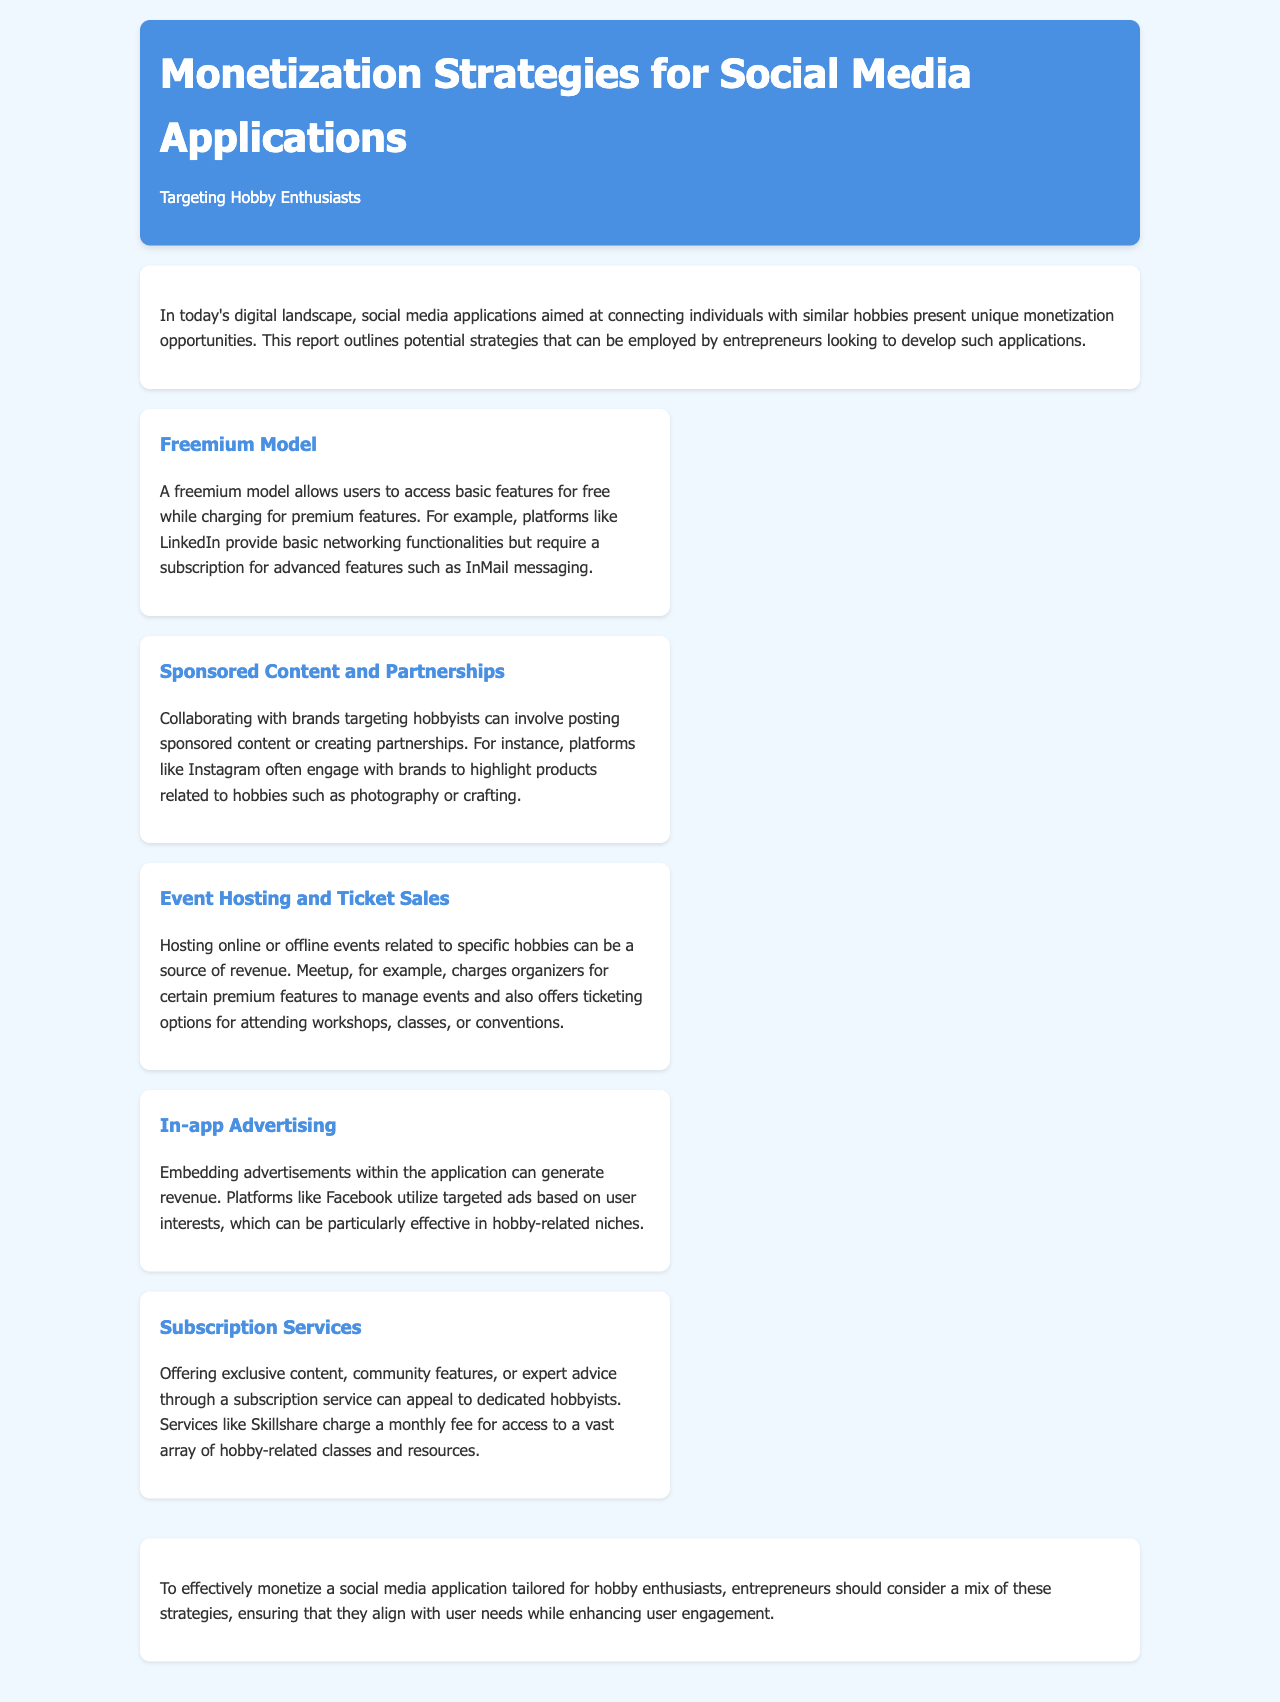What is the purpose of the report? The report outlines potential strategies that can be employed by entrepreneurs looking to develop social media applications for connecting hobby enthusiasts.
Answer: monetization strategies What is the first monetization strategy mentioned? The first strategy listed under the monetization strategies section is aimed at generating revenue by allowing users to access basic features for free while charging for premium features.
Answer: Freemium Model Which platform is referenced as using a freemium model? The report refers to a specific platform that exemplifies the freemium model by providing basic networking functionalities and requiring a subscription for advanced features.
Answer: LinkedIn What type of revenue does the Event Hosting and Ticket Sales strategy involve? The strategy discusses generating revenue through organizing online or offline events related to specific hobbies and also through ticket sales.
Answer: ticket sales Which monetization strategy involves collaborations with brands? The strategy that involves working with brands and posting sponsored content or creating partnerships is known for highlighting products related to hobbies.
Answer: Sponsored Content and Partnerships How does in-app advertising generate revenue? In-app advertising generates revenue by embedding advertisements within the application, utilizing targeted ads based on user interests.
Answer: targeted ads What is the example given for a subscription service in the report? The report mentions a specific service that charges a monthly fee for access to hobby-related classes and resources.
Answer: Skillshare What is the concluding suggestion for entrepreneurs? The report suggests that to effectively monetize a social media application tailored for hobby enthusiasts, entrepreneurs should consider a mix of strategies that align with user needs.
Answer: mix of strategies 